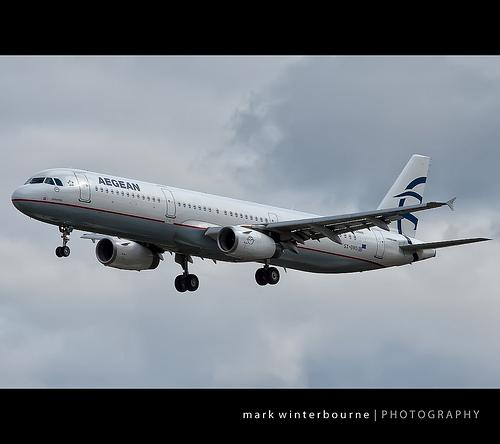Count the number of doors on the left side of the plane and mention their position. There are three doors on the left side of the plane: front, middle, and back. Describe the logos and letterings that can be found on the plane, including their colors. There is "Aegean" written in dark blue, a large blue symbol on the tail, and white letters "a", "b", "e", "g", "h", "i", "m", "k", and "r" on the side of the plane. Provide a short description of the overall scene captured in the image. A grey, red, and white passenger jet with Aegean written on the side is flying in a cloudy sky with its landing gear down and two engines visible. What type of plane is depicted in the image, and what is its primary purpose? The image shows a passenger jet, primarily used to transport people. Identify and describe the plane's unique features and their corresponding colors. The plane has Aegean written in dark blue, a large blue symbol on its tail, and many small windows on its side. The wings are grey, and there are two large engines. What is the weather like in the background of the image, and how does it affect the overall atmosphere? The weather is cloudy with dark clouds, setting a somewhat dramatic and moody atmosphere for the image. What unique marking related to the photographer can be found on this image? A watermark that says "Mark Winterbourne Photography" in white is present in the image. Analyze the emotion or sentiment this image may evoke in the viewer. The image may evoke a sense of curiosity or awe due to the dramatic cloudy sky, and interest in the large passenger jet with its colorful and detailed markings. State the number of engines visible on the plane and provide a brief description of their color and size. There are two large engines visible on the plane, which appear to be gray and quite large. What is the primary action happening in the image? A large passenger jet is flying in the sky, positioned at a slight upward angle. What is the position of the plane in the sky? at a slight upward angle What do you think about the presence of a large banner trailing behind the plane advertising a new movie release? This statement is misleading because there is no mention of a banner or any advertisement related to the plane in the given information. This distracts the viewer from the true details of the image, such as the text "mark winterbourne photography" and the airline's name "aegean" on the side of the plane. Which of the following best describes the watermarked text on the image: mark winterbourne photography? This watermark identifies the photographer of the image. Find the coordinates of the plane's tail. X:361 Y:145 Width:81 Height:81 The sun can be seen shining brightly as it sets in the distant horizon. This statement is misleading because there is no mention of the sun or a sunset in the given information. Instead, the focus is on the plane and its details. Additionally, the sky is described as "cloudy" and "large gray sky," which does not align with the idea of a bright and sunny scene. Determine if any part of the image is unusual or unexpected. no anomalies detected Is there any interaction between the plane's engines and wings in the image? Yes, the engines are attached to the wings Describe the sky in the image. cloudy and large gray Can you spot any clouds in the sky? Yes, beautiful white clouds Observe the red parachute attached to the plane's tail, ready to be deployed in case of an emergency. No, it's not mentioned in the image. Rate the overall quality of the image on a scale of 1 to 10. 9 Notice the flock of birds flying closely behind the plane and making interesting patterns. This instruction is misleading as there are no birds mentioned in the given information, nor are any patterns mentioned. A flock of birds following the plane would be quite unusual, making this statement more confusing for the viewer. What is the watermark on the image? mark winterbourne photography What type of vehicle is the object in the image? a passenger jet What words are written in white font on the image? the letters a, b, e, g, h, i, m, k, r Could you spot the purple and green hot air balloon near the top right corner of the image? There is no mention of a hot air balloon in the given information, so it is misleading to ask someone to find it. The colors purple and green are also not mentioned, which adds to the confusion. Describe the plane, based on its attributes. a passenger jet; white, grey, and red, with blue font on the side Can you identify the small group of people waving from the windows of the plane? This instruction is misleading because there is no mention of people in the given information, particularly people waving from the windows. It distracts the viewer from the actual details, such as the plane's many small windows and its features. Identify the color of the airplane in the image. grey, red, and white Does the plane have landing gears? Yes, landing gear is down In the image, locate the caption that says "aegean is on the side of the plane in dark blue." X:62 Y:155 Width:90 Height:90 What symbols appear on the tail of the plane? a large blue symbol How many engines does the plane have in the picture? two engines How many doors are there on the left side of the image? three doors Notify if sunset or clouds dominate the background clouds dominate the background What are the colors of the font on the plane? white and blue 